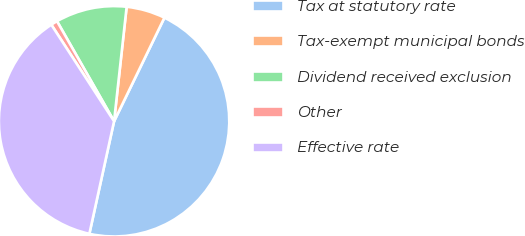<chart> <loc_0><loc_0><loc_500><loc_500><pie_chart><fcel>Tax at statutory rate<fcel>Tax-exempt municipal bonds<fcel>Dividend received exclusion<fcel>Other<fcel>Effective rate<nl><fcel>46.24%<fcel>5.46%<fcel>9.99%<fcel>0.92%<fcel>37.39%<nl></chart> 